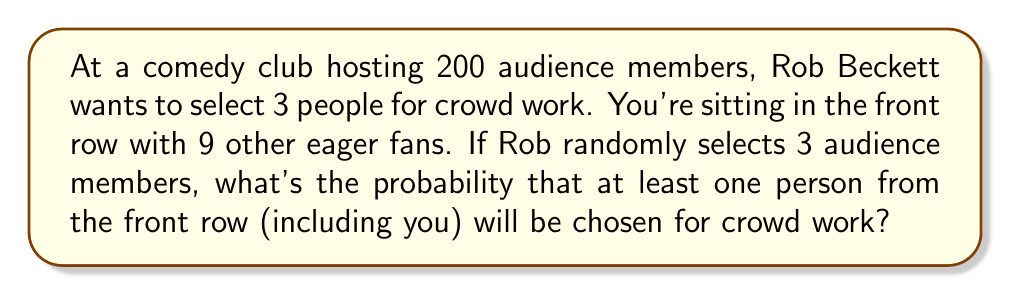Solve this math problem. Let's approach this step-by-step:

1) First, let's calculate the total number of ways to choose 3 people from 200 audience members:
   $$\binom{200}{3} = \frac{200!}{3!(200-3)!} = \frac{200!}{3!197!} = 1,313,400$$

2) Now, instead of calculating the probability of at least one front row person being chosen, it's easier to calculate the probability of no front row person being chosen and then subtract this from 1.

3) To choose 3 people with none from the front row, we need to choose all 3 from the remaining 190 people:
   $$\binom{190}{3} = \frac{190!}{3!187!} = 1,140,030$$

4) The probability of choosing no one from the front row is:
   $$P(\text{no front row}) = \frac{1,140,030}{1,313,400} \approx 0.8680$$

5) Therefore, the probability of choosing at least one person from the front row is:
   $$P(\text{at least one front row}) = 1 - P(\text{no front row}) = 1 - 0.8680 = 0.1320$$

6) Converting to a percentage:
   $$0.1320 \times 100\% = 13.20\%$$
Answer: The probability is approximately 13.20% or 0.1320. 